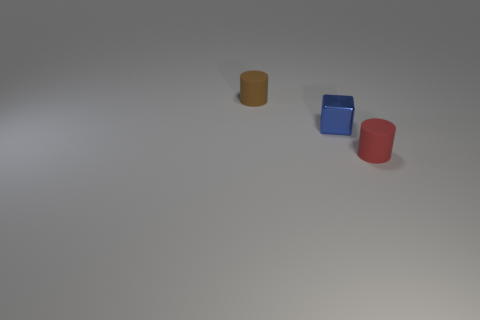The object that is in front of the brown thing and behind the red rubber object is what color? The object in question, which is situated between the brown cylinder on one side and the red cylinder on the other, exhibits a rich blue color. The soft shadows around it accentuate the tone, creating a visually pleasing contrast with the other objects nearby. 